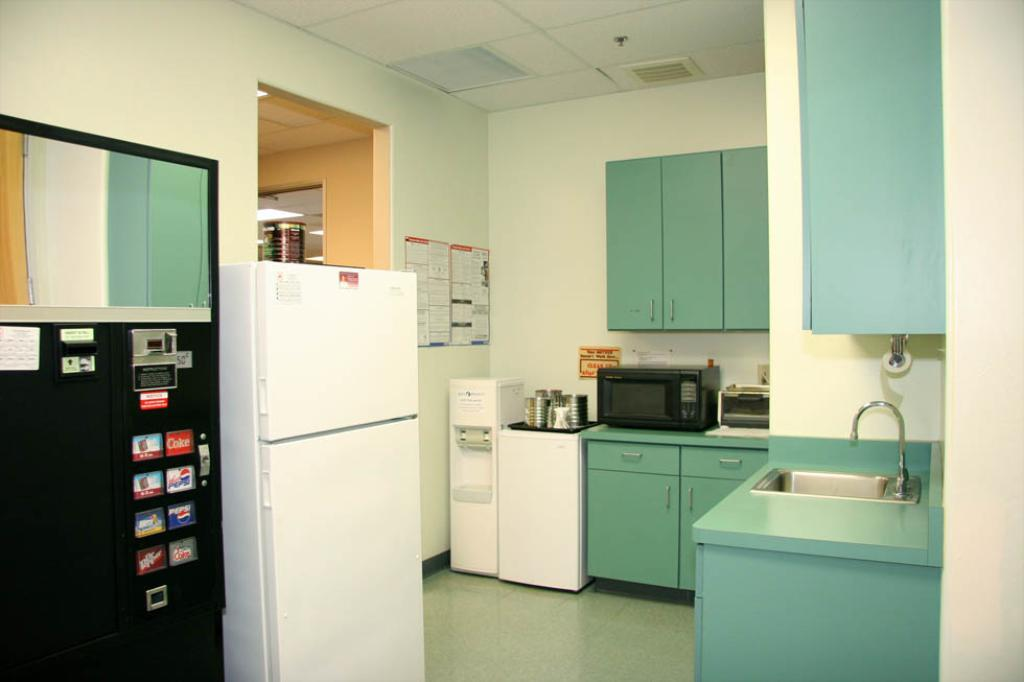<image>
Provide a brief description of the given image. A clean kitchen with blue cabinets and a vending machine that sells coke products to the left of the fridge. 